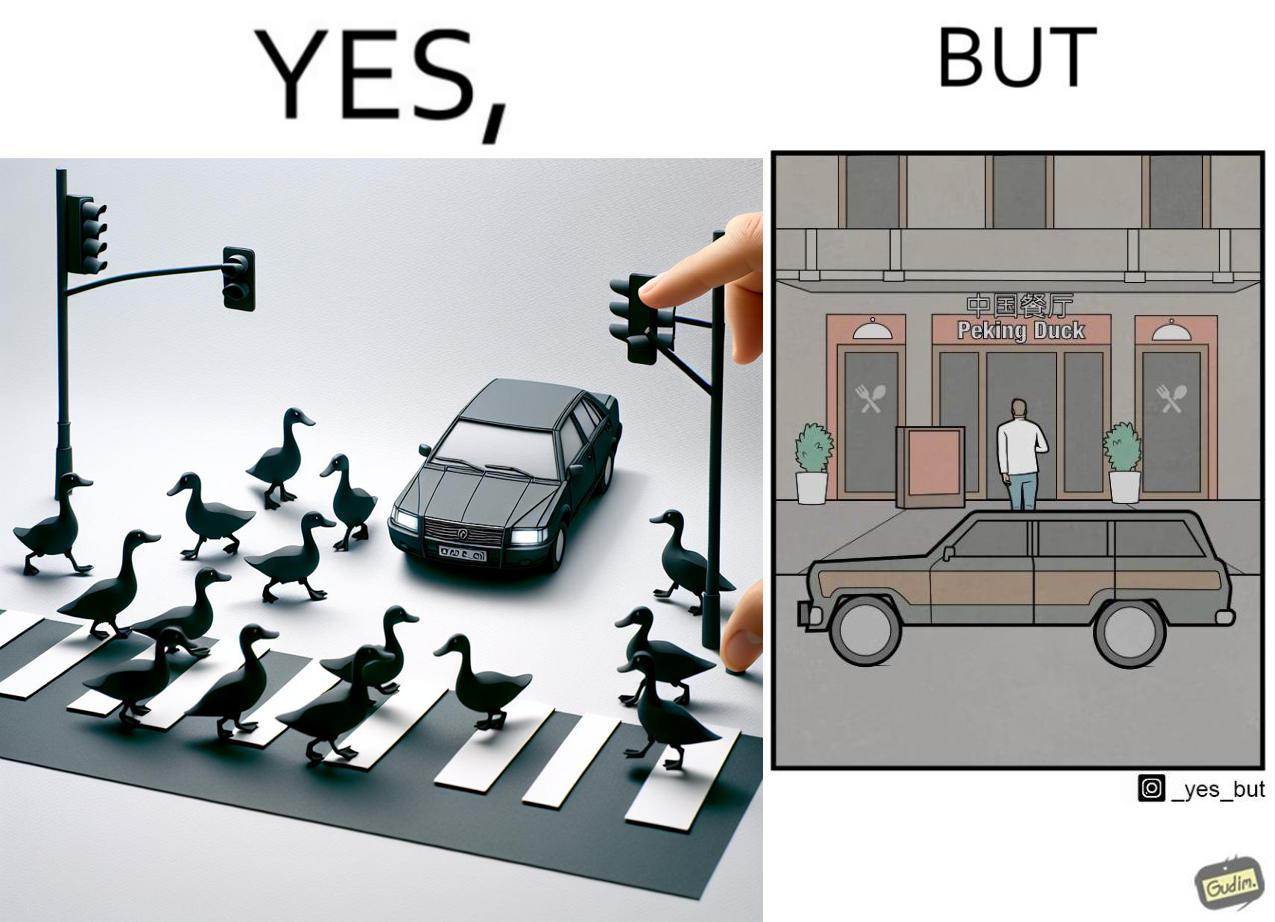Does this image contain satire or humor? Yes, this image is satirical. 